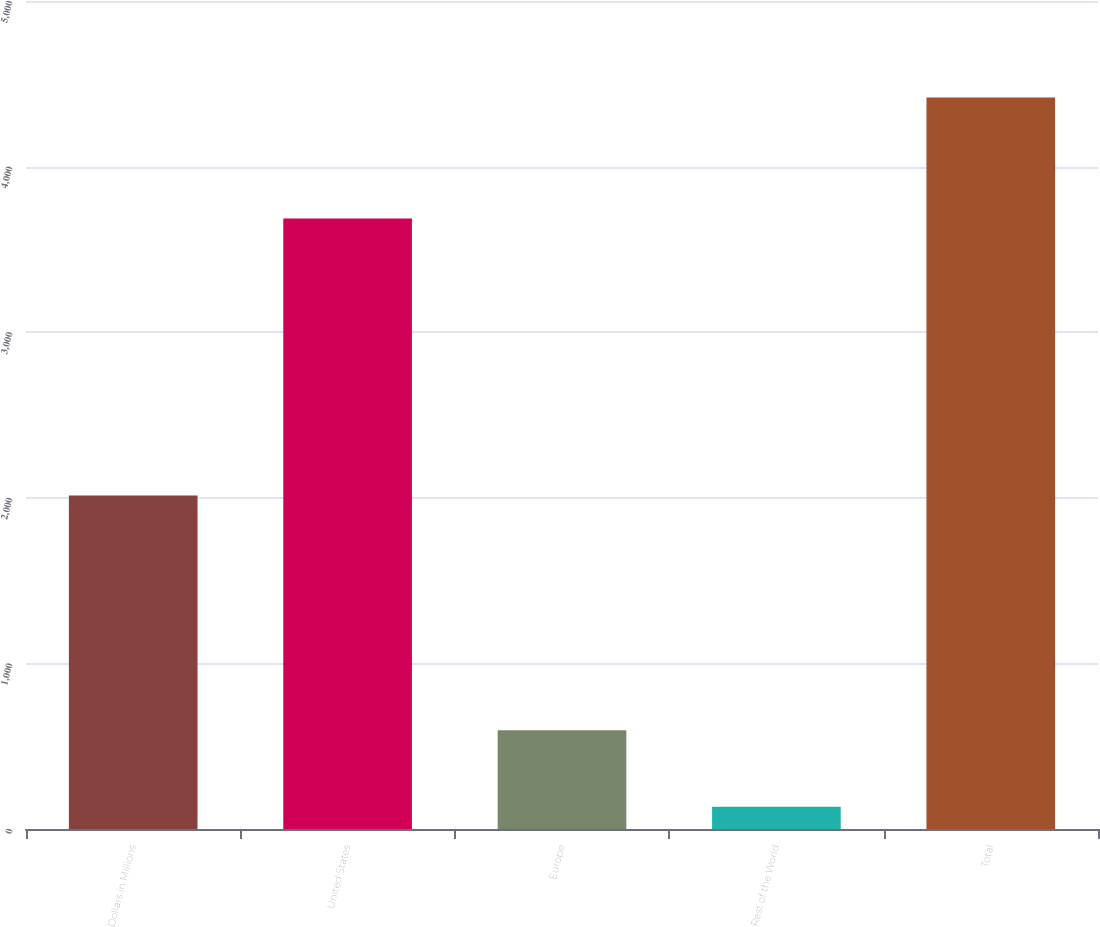Convert chart to OTSL. <chart><loc_0><loc_0><loc_500><loc_500><bar_chart><fcel>Dollars in Millions<fcel>United States<fcel>Europe<fcel>Rest of the World<fcel>Total<nl><fcel>2014<fcel>3686<fcel>597<fcel>134<fcel>4417<nl></chart> 